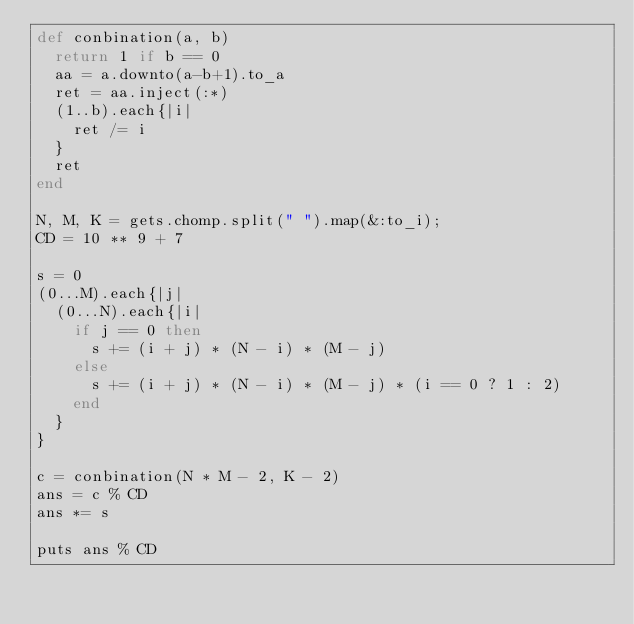<code> <loc_0><loc_0><loc_500><loc_500><_Ruby_>def conbination(a, b)
  return 1 if b == 0
  aa = a.downto(a-b+1).to_a
  ret = aa.inject(:*)
  (1..b).each{|i|
    ret /= i
  }
  ret
end

N, M, K = gets.chomp.split(" ").map(&:to_i);
CD = 10 ** 9 + 7

s = 0
(0...M).each{|j|
  (0...N).each{|i|
    if j == 0 then
      s += (i + j) * (N - i) * (M - j)
    else
      s += (i + j) * (N - i) * (M - j) * (i == 0 ? 1 : 2)
    end
  }
}

c = conbination(N * M - 2, K - 2)
ans = c % CD
ans *= s

puts ans % CD
</code> 